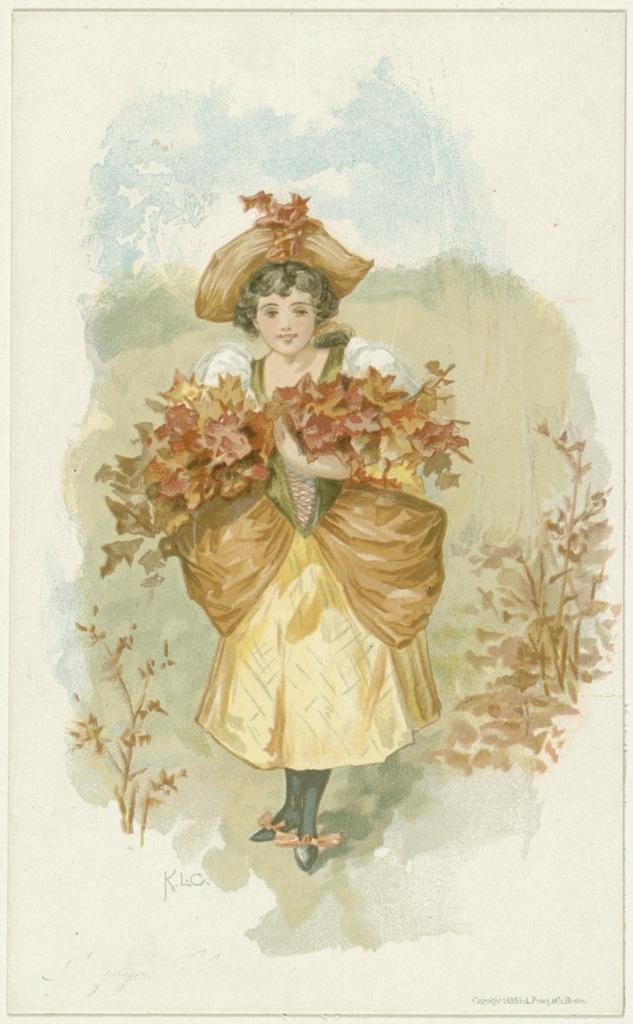What type of artwork is depicted in the image? The image is a painting. Who or what is the main subject of the painting? There is a girl in the painting. What is the girl holding in the painting? The girl is holding flowers. What accessory is the girl wearing in the painting? The girl is wearing a hat. What can be seen on either side of the painting? There are plants on either side of the painting. What type of breakfast is the girl eating in the painting? There is no breakfast depicted in the painting; the girl is holding flowers and wearing a hat. Can you see any visible veins on the girl's hands in the painting? The painting does not show any visible veins on the girl's hands, as it focuses on the girl holding flowers and wearing a hat. 